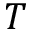<formula> <loc_0><loc_0><loc_500><loc_500>T</formula> 